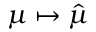Convert formula to latex. <formula><loc_0><loc_0><loc_500><loc_500>\mu \mapsto { \hat { \mu } }</formula> 